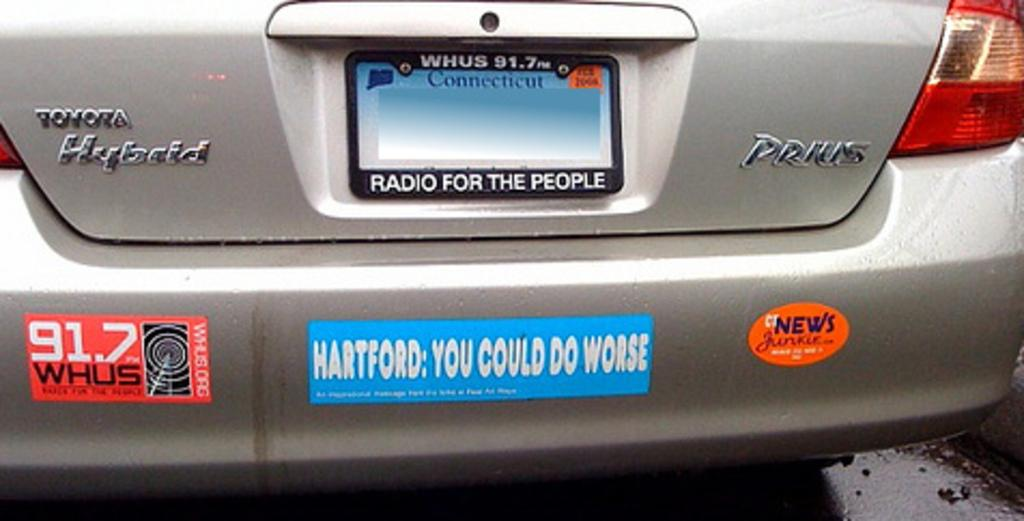<image>
Share a concise interpretation of the image provided. A silver car has bumper stickers on it and says Toyota Hybrid on the back. 